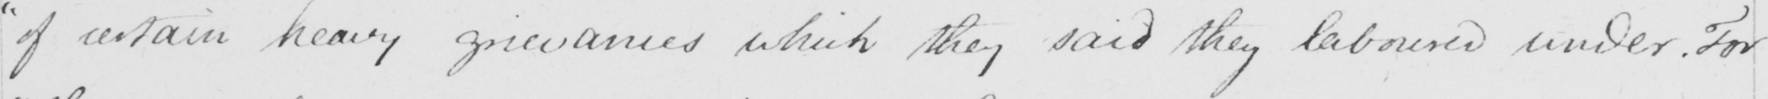Can you tell me what this handwritten text says? " of certain heavy grievances which they said they laboured under . For 